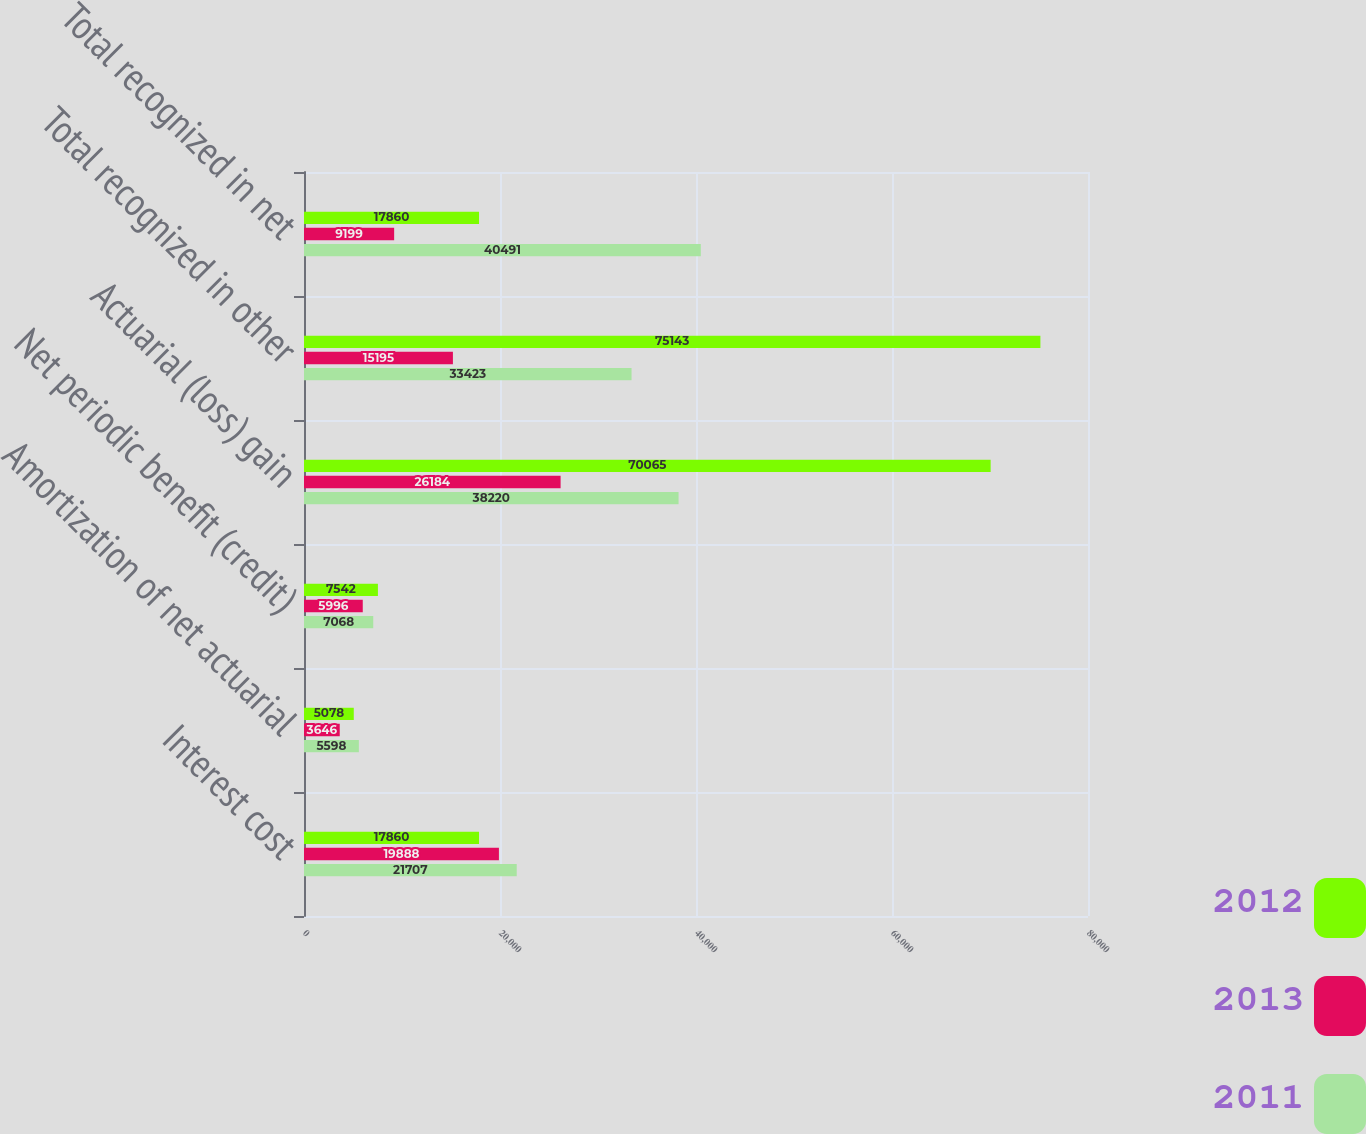Convert chart to OTSL. <chart><loc_0><loc_0><loc_500><loc_500><stacked_bar_chart><ecel><fcel>Interest cost<fcel>Amortization of net actuarial<fcel>Net periodic benefit (credit)<fcel>Actuarial (loss) gain<fcel>Total recognized in other<fcel>Total recognized in net<nl><fcel>2012<fcel>17860<fcel>5078<fcel>7542<fcel>70065<fcel>75143<fcel>17860<nl><fcel>2013<fcel>19888<fcel>3646<fcel>5996<fcel>26184<fcel>15195<fcel>9199<nl><fcel>2011<fcel>21707<fcel>5598<fcel>7068<fcel>38220<fcel>33423<fcel>40491<nl></chart> 